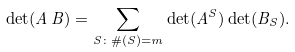<formula> <loc_0><loc_0><loc_500><loc_500>\det ( A \, B ) = \sum _ { S \colon \# ( S ) = m } \det ( A ^ { S } ) \det ( B _ { S } ) .</formula> 